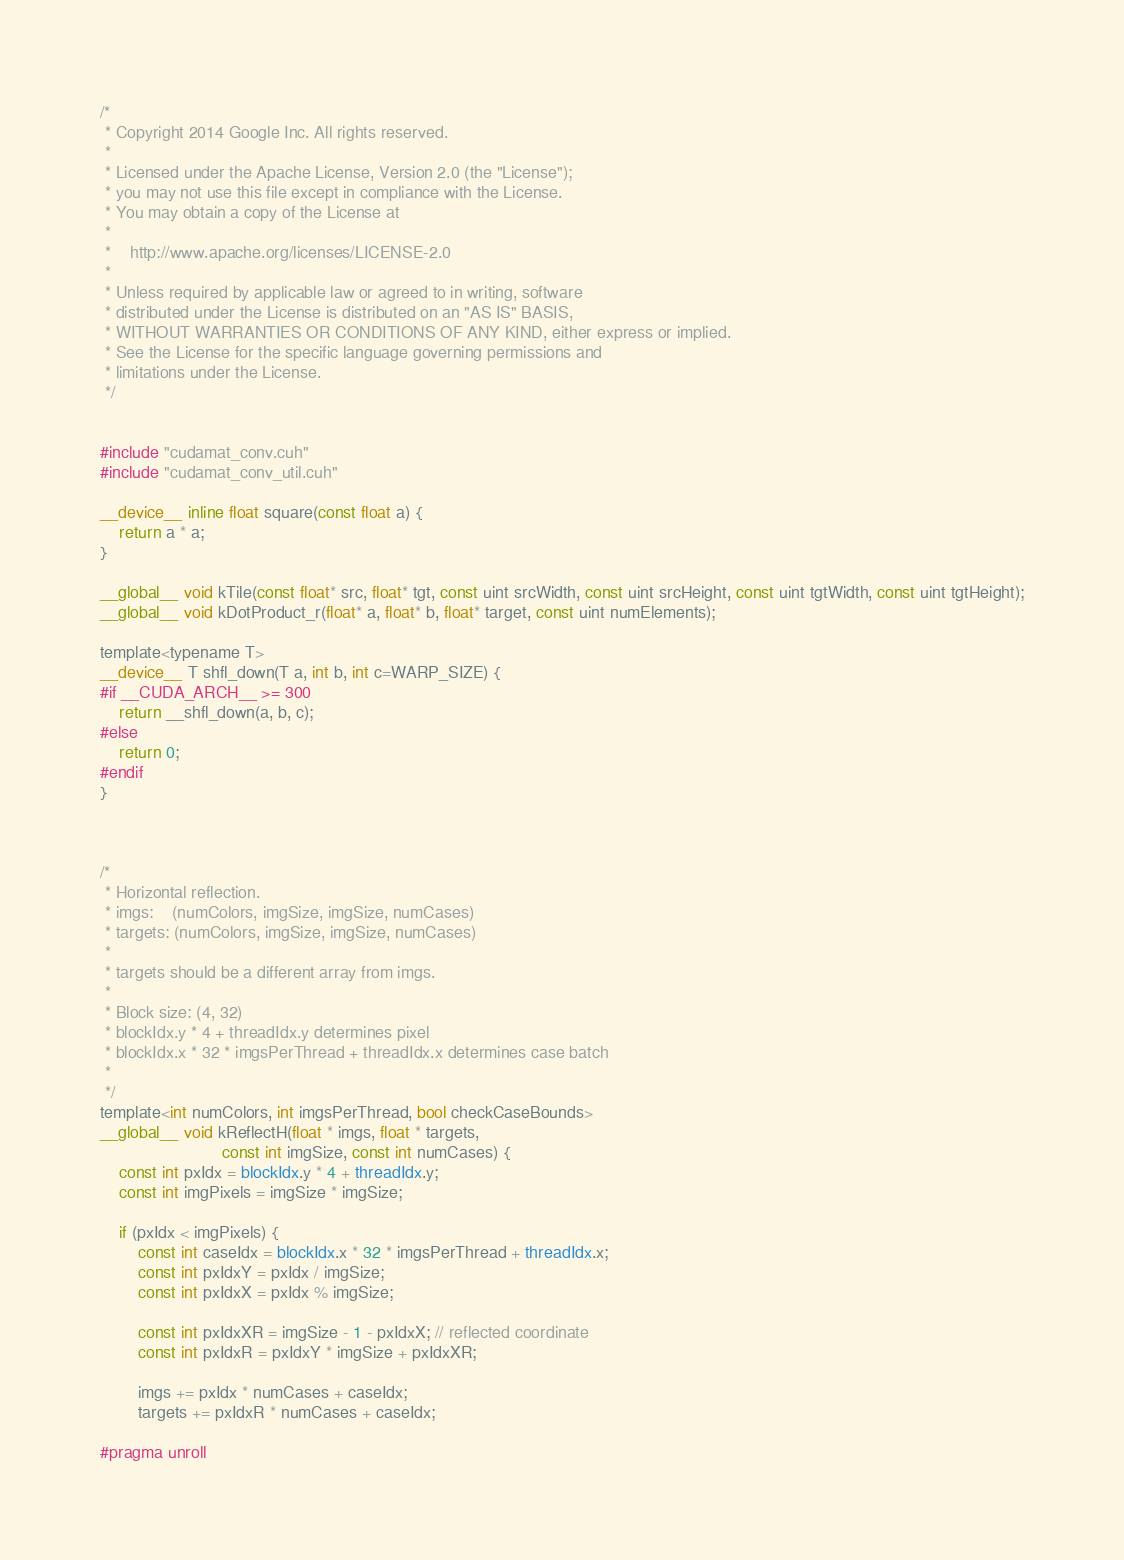Convert code to text. <code><loc_0><loc_0><loc_500><loc_500><_Cuda_>/*
 * Copyright 2014 Google Inc. All rights reserved.
 *
 * Licensed under the Apache License, Version 2.0 (the "License");
 * you may not use this file except in compliance with the License.
 * You may obtain a copy of the License at
 *
 *    http://www.apache.org/licenses/LICENSE-2.0
 *
 * Unless required by applicable law or agreed to in writing, software
 * distributed under the License is distributed on an "AS IS" BASIS,
 * WITHOUT WARRANTIES OR CONDITIONS OF ANY KIND, either express or implied.
 * See the License for the specific language governing permissions and
 * limitations under the License.
 */


#include "cudamat_conv.cuh"
#include "cudamat_conv_util.cuh"

__device__ inline float square(const float a) {
    return a * a;
}

__global__ void kTile(const float* src, float* tgt, const uint srcWidth, const uint srcHeight, const uint tgtWidth, const uint tgtHeight);
__global__ void kDotProduct_r(float* a, float* b, float* target, const uint numElements);

template<typename T> 
__device__ T shfl_down(T a, int b, int c=WARP_SIZE) {
#if __CUDA_ARCH__ >= 300
    return __shfl_down(a, b, c);
#else
    return 0;
#endif
}



/*
 * Horizontal reflection.
 * imgs:    (numColors, imgSize, imgSize, numCases)
 * targets: (numColors, imgSize, imgSize, numCases)
 * 
 * targets should be a different array from imgs.
 * 
 * Block size: (4, 32)
 * blockIdx.y * 4 + threadIdx.y determines pixel
 * blockIdx.x * 32 * imgsPerThread + threadIdx.x determines case batch
 * 
 */
template<int numColors, int imgsPerThread, bool checkCaseBounds>
__global__ void kReflectH(float * imgs, float * targets,
                          const int imgSize, const int numCases) {
    const int pxIdx = blockIdx.y * 4 + threadIdx.y;
    const int imgPixels = imgSize * imgSize;
    
    if (pxIdx < imgPixels) {
        const int caseIdx = blockIdx.x * 32 * imgsPerThread + threadIdx.x;
        const int pxIdxY = pxIdx / imgSize;
        const int pxIdxX = pxIdx % imgSize;

        const int pxIdxXR = imgSize - 1 - pxIdxX; // reflected coordinate
        const int pxIdxR = pxIdxY * imgSize + pxIdxXR;

        imgs += pxIdx * numCases + caseIdx;
        targets += pxIdxR * numCases + caseIdx;

#pragma unroll</code> 